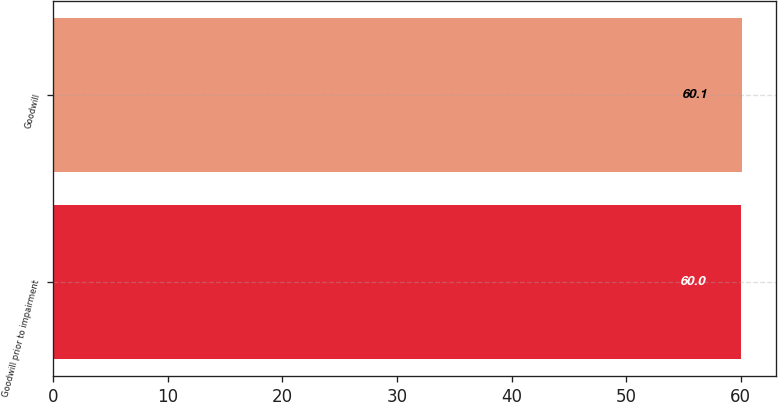Convert chart. <chart><loc_0><loc_0><loc_500><loc_500><bar_chart><fcel>Goodwill prior to impairment<fcel>Goodwill<nl><fcel>60<fcel>60.1<nl></chart> 